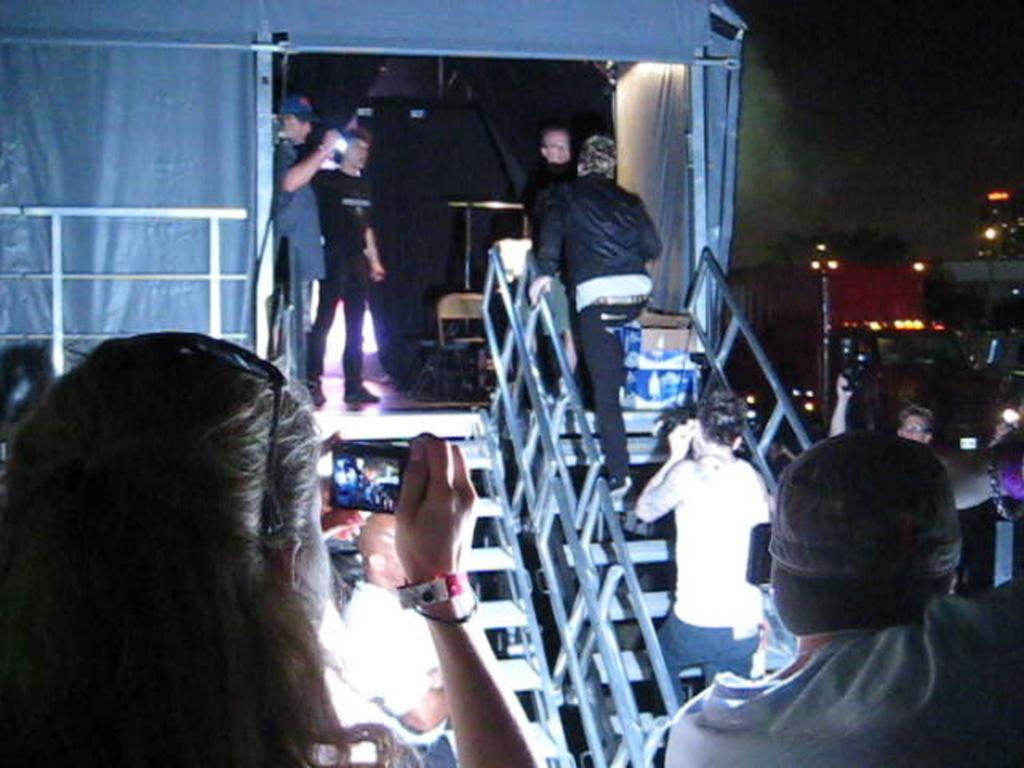Who is at the bottom of the image? There is a woman at the bottom of the image. What is the woman holding? The woman is holding a mobile. How many people are in the image? There is one person (the woman) at the bottom and more people in the middle of the image. What can be seen in the middle of the image? There is a staircase, lights, buildings, and a stage in the middle of the image. What type of brick is being used to stitch the finger in the image? There is no brick, stitching, or finger present in the image. 